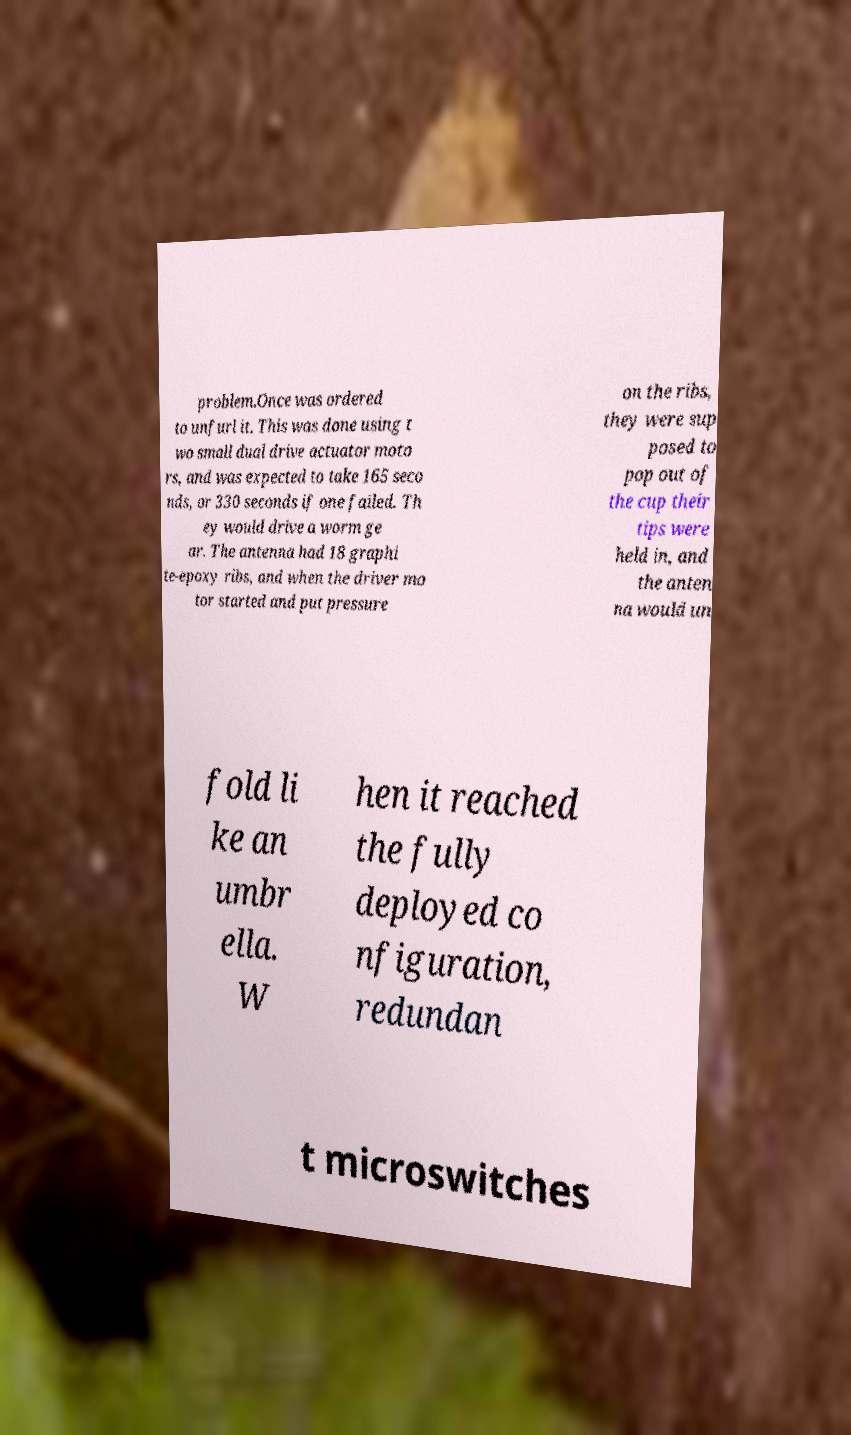What messages or text are displayed in this image? I need them in a readable, typed format. problem.Once was ordered to unfurl it. This was done using t wo small dual drive actuator moto rs, and was expected to take 165 seco nds, or 330 seconds if one failed. Th ey would drive a worm ge ar. The antenna had 18 graphi te-epoxy ribs, and when the driver mo tor started and put pressure on the ribs, they were sup posed to pop out of the cup their tips were held in, and the anten na would un fold li ke an umbr ella. W hen it reached the fully deployed co nfiguration, redundan t microswitches 